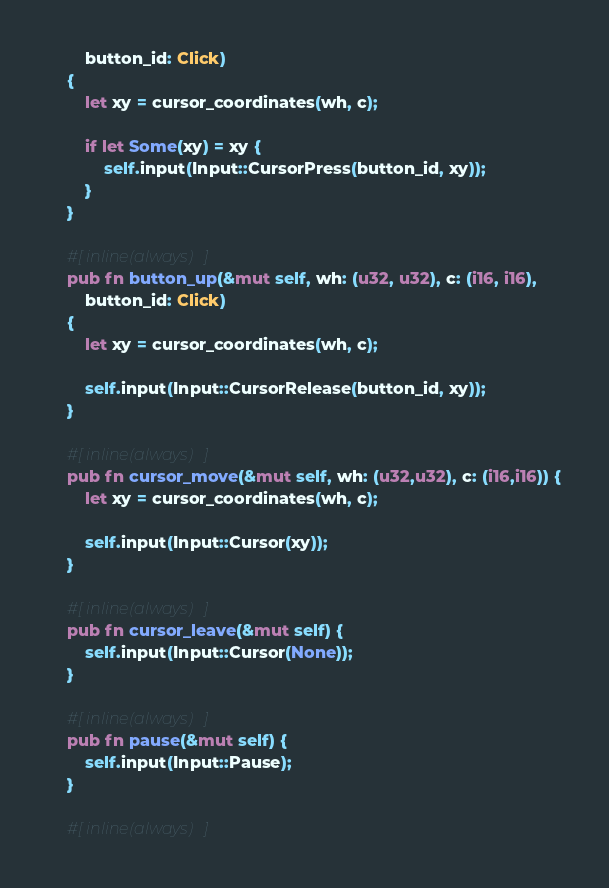Convert code to text. <code><loc_0><loc_0><loc_500><loc_500><_Rust_>		button_id: Click)
	{
		let xy = cursor_coordinates(wh, c);

		if let Some(xy) = xy {
			self.input(Input::CursorPress(button_id, xy));
		}
	}

	#[inline(always)]
	pub fn button_up(&mut self, wh: (u32, u32), c: (i16, i16),
		button_id: Click)
	{
		let xy = cursor_coordinates(wh, c);

		self.input(Input::CursorRelease(button_id, xy));
	}

	#[inline(always)]
	pub fn cursor_move(&mut self, wh: (u32,u32), c: (i16,i16)) {
		let xy = cursor_coordinates(wh, c);

		self.input(Input::Cursor(xy));
	}

	#[inline(always)]
	pub fn cursor_leave(&mut self) {
		self.input(Input::Cursor(None));
	}

	#[inline(always)]
	pub fn pause(&mut self) {
		self.input(Input::Pause);
	}

	#[inline(always)]</code> 